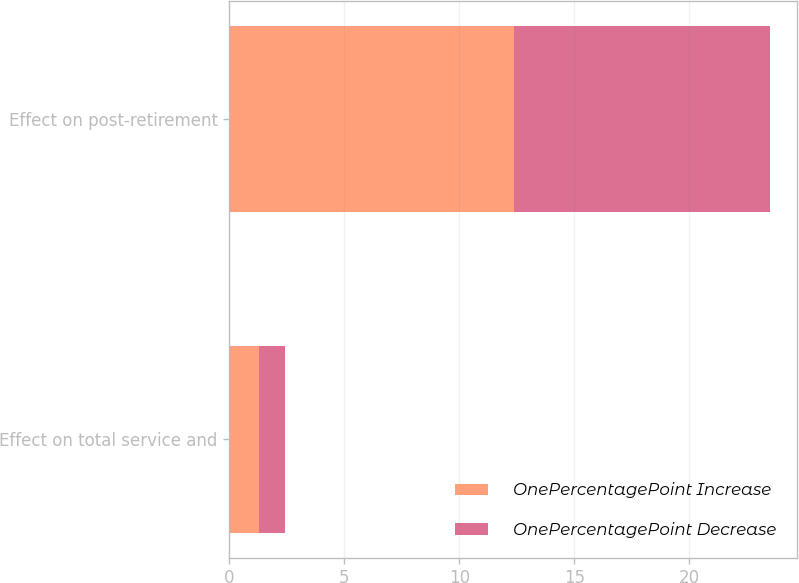Convert chart. <chart><loc_0><loc_0><loc_500><loc_500><stacked_bar_chart><ecel><fcel>Effect on total service and<fcel>Effect on post-retirement<nl><fcel>OnePercentagePoint Increase<fcel>1.3<fcel>12.4<nl><fcel>OnePercentagePoint Decrease<fcel>1.1<fcel>11.1<nl></chart> 